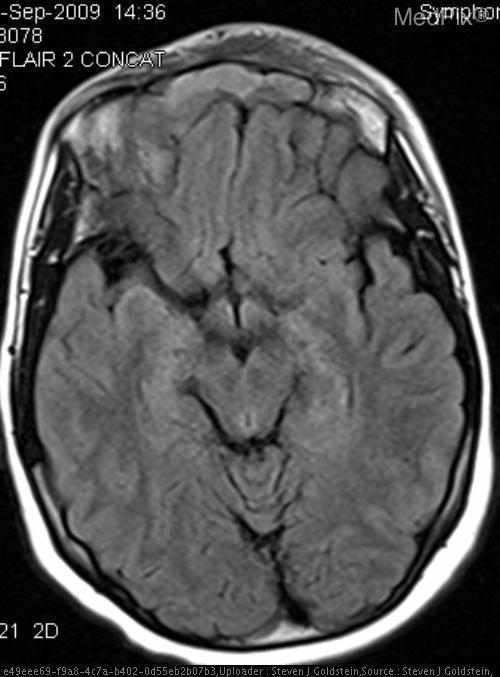Is this picture abnormal?
Give a very brief answer. Yes. What is the alternate name for lens-shaped""
Concise answer only. Lentiform. What term is synonymous with lens-shaped?
Quick response, please. Biconvex. What is the most likely diagnosis?
Write a very short answer. Epidural hematoma. What is going on with this patient?
Concise answer only. Sinusitis. What shape would the lesion be if this were a subdural hematoma?
Keep it brief. Crescent. What shape is the lesion in a subdural hematoma?
Quick response, please. Concave. 